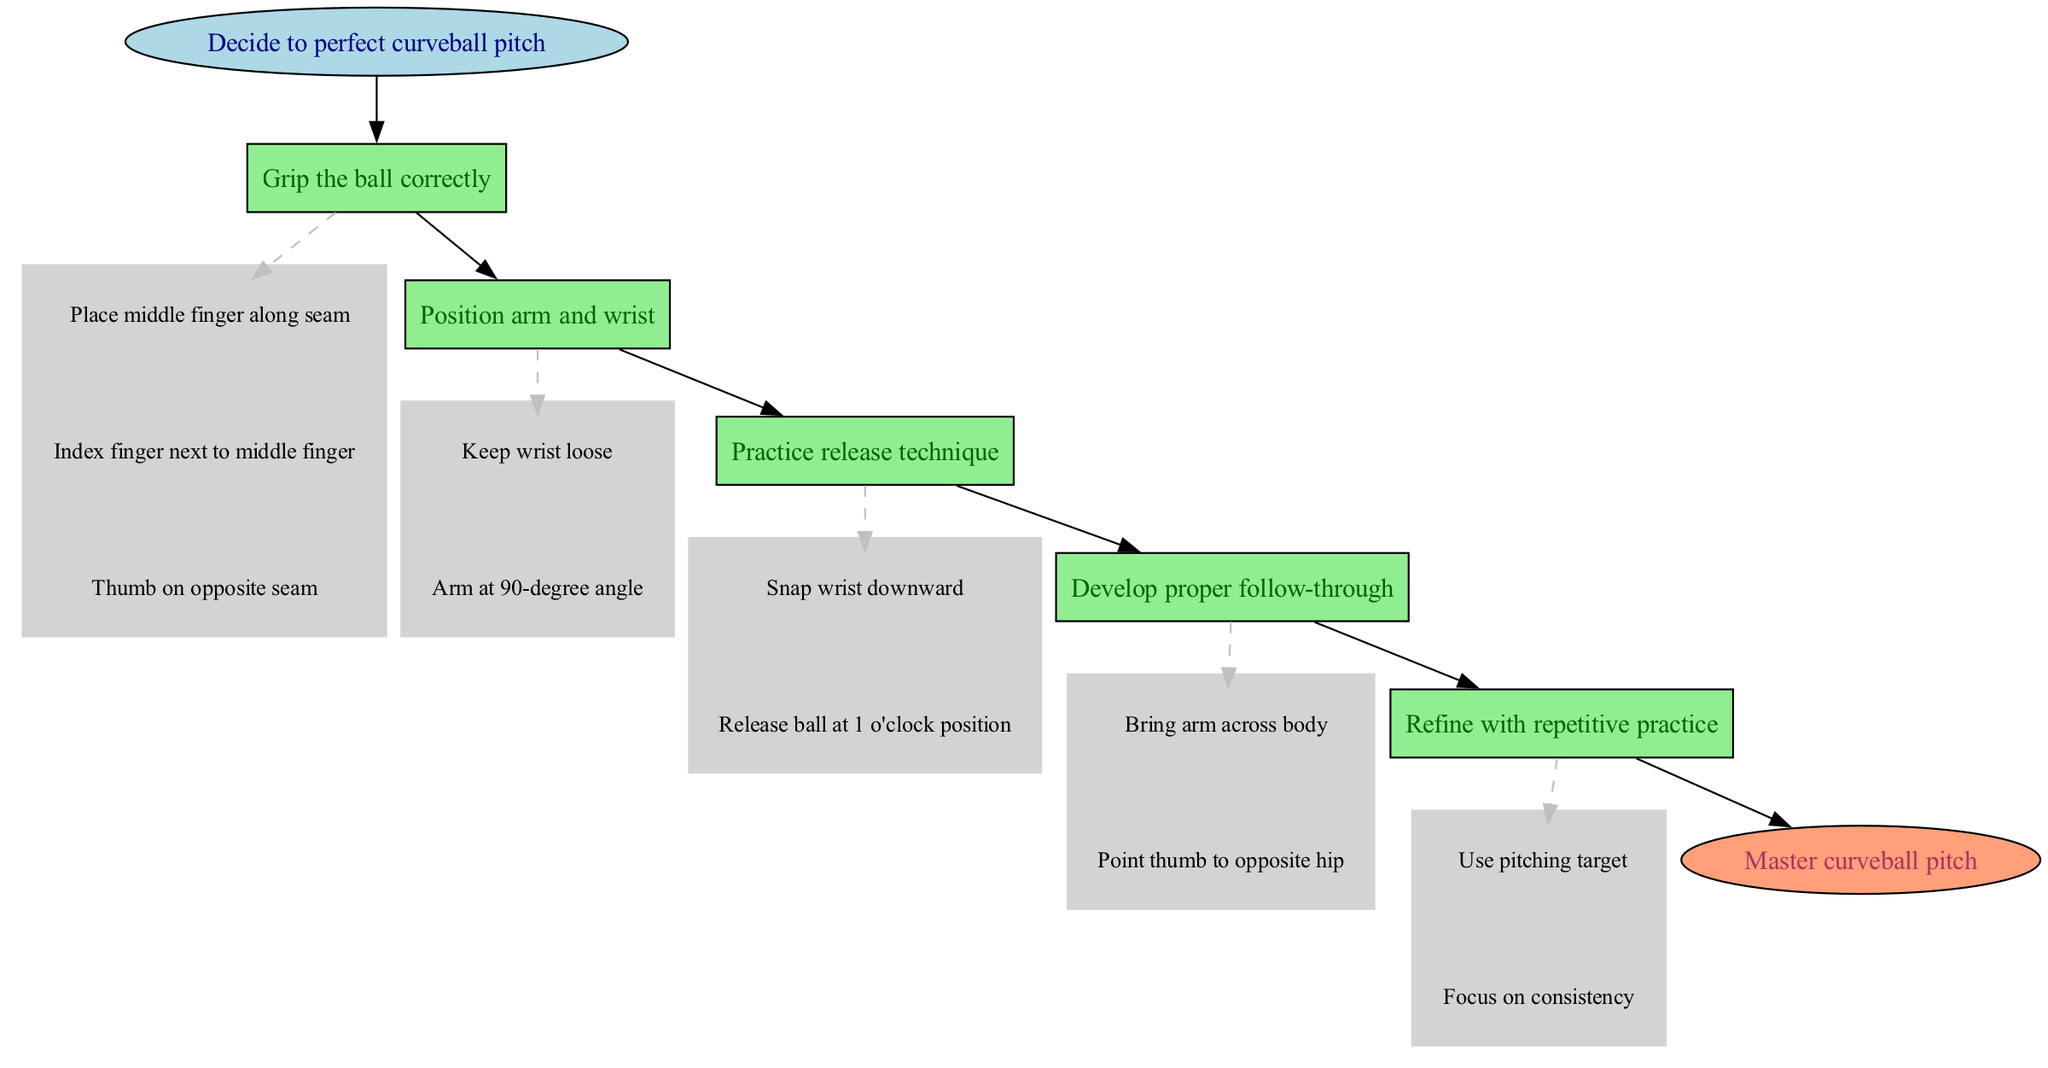What is the starting point in the diagram? The starting point is labeled as "Decide to perfect curveball pitch," which is indicated as the initial node in the flow chart.
Answer: Decide to perfect curveball pitch How many main steps are there to master the curveball pitch? The diagram lists 5 main steps, each represented by a distinct box leading towards the final goal, indicating the sequence needed to achieve mastery.
Answer: 5 What is the last step before mastering the curveball pitch? The last step before reaching mastery is "Refine with repetitive practice," which is the fifth box in the progression of steps in the diagram.
Answer: Refine with repetitive practice What does the first step in the process involve? The first step is "Grip the ball correctly," which is connected directly from the starting point and requires specific actions related to hand placement on the ball.
Answer: Grip the ball correctly Which detail follows "Position arm and wrist"? The detail that follows "Position arm and wrist" in the subgraph is "Arm at 90-degree angle," representing the sequence of instructions required for that step.
Answer: Arm at 90-degree angle If someone completes all the steps, what will they achieve? Completing all steps leads to the endpoint of the process, which is clearly defined in the diagram as "Master curveball pitch."
Answer: Master curveball pitch Which detail is associated with practicing the release technique? The details provided under "Practice release technique" include "Snap wrist downward," which directly connects to the arm movement crucial for executing the pitch correctly.
Answer: Snap wrist downward What is indicated by the dashed line in the diagram? The dashed line is used to connect the main step "Grip the ball correctly" to its first detail, signifying a specific instruction that follows from that step in the flow chart.
Answer: Dashed line indicates connection What is the specific action mentioned for the follow-through step? The follow-through step specifies the action "Bring arm across body," indicating the necessary movement after releasing the pitch to complete the technique.
Answer: Bring arm across body 